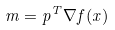Convert formula to latex. <formula><loc_0><loc_0><loc_500><loc_500>m = p ^ { T } \nabla f ( x )</formula> 